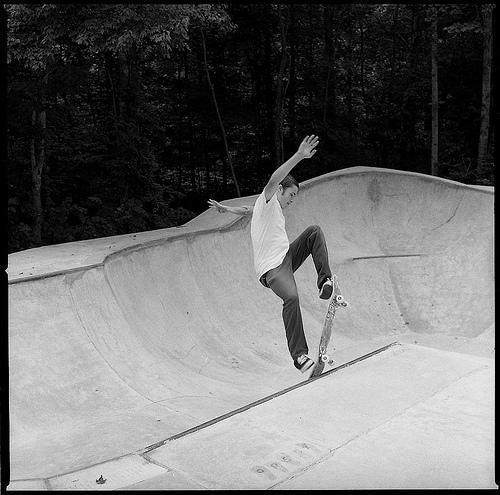How many people are visible?
Give a very brief answer. 1. How many clock faces are there?
Give a very brief answer. 0. 